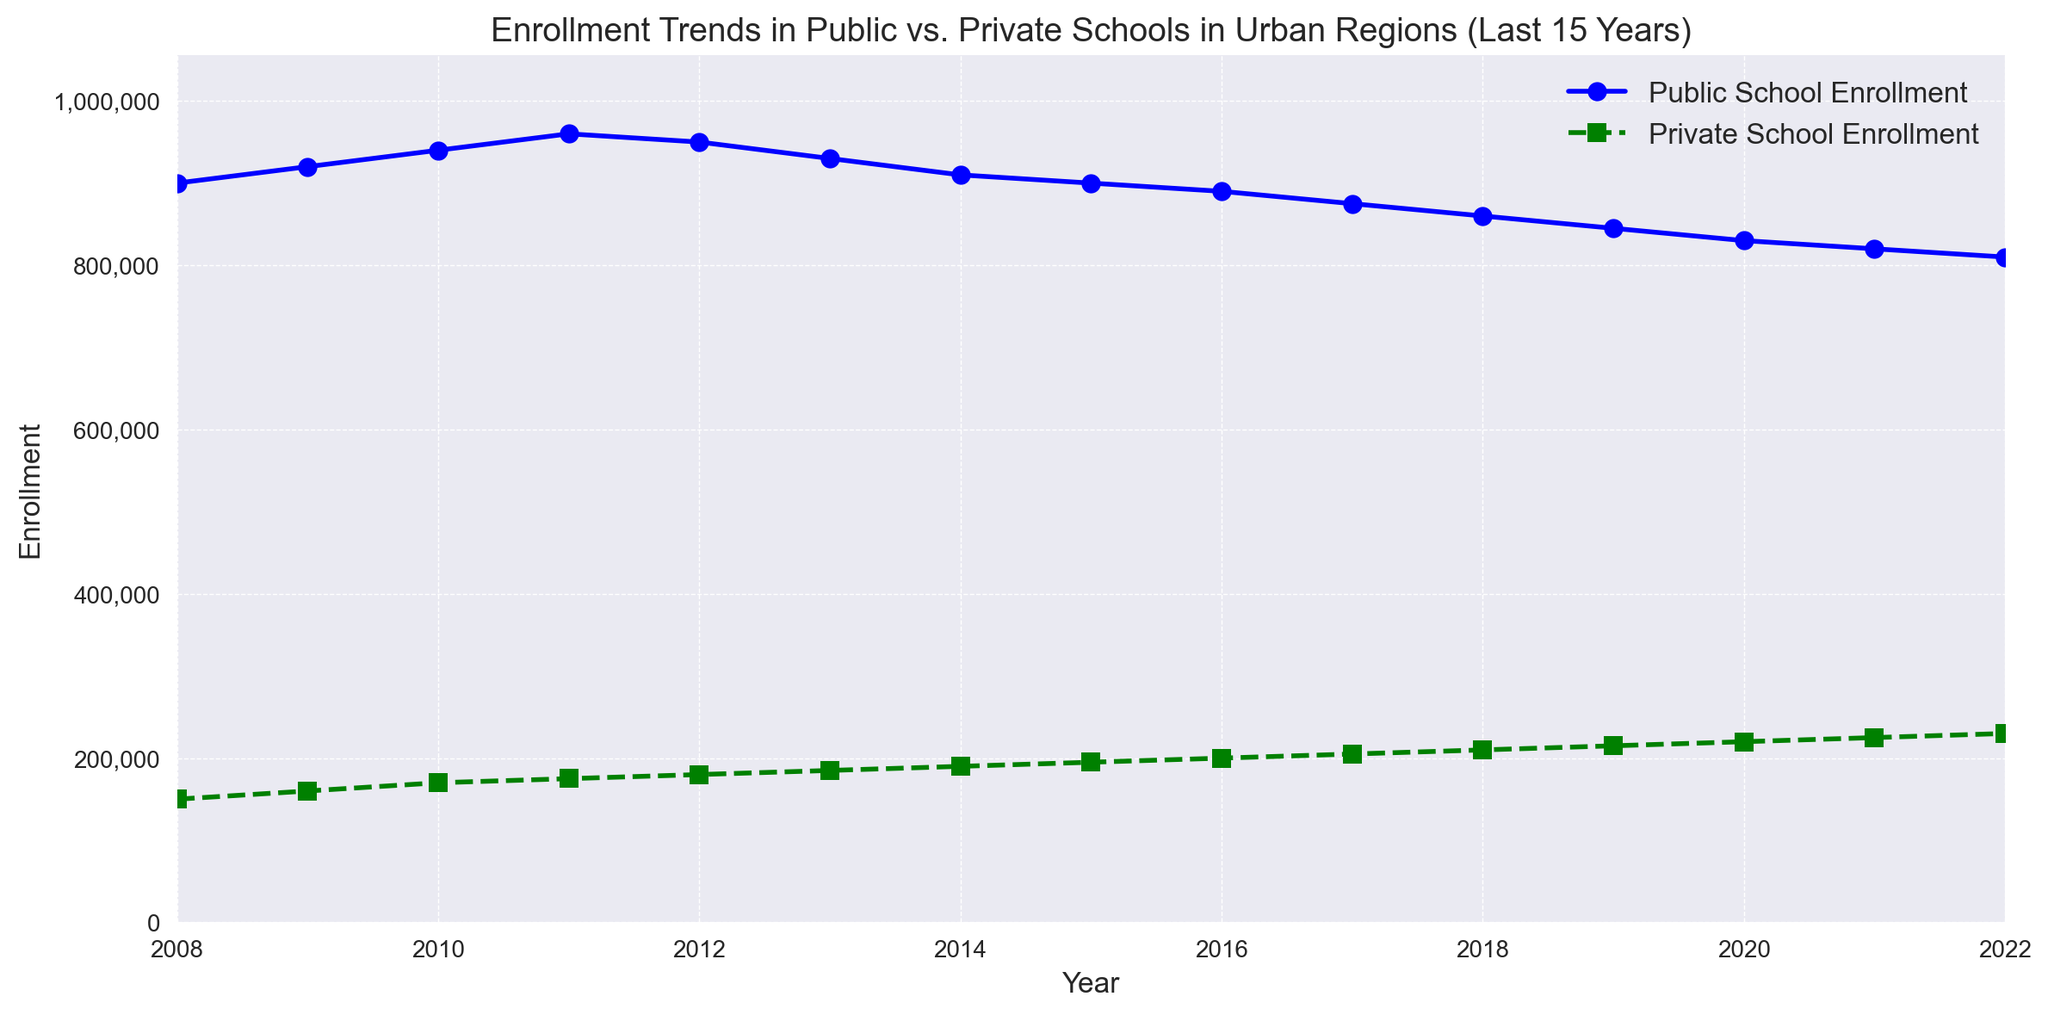What's the trend of Public School Enrollment over the last 15 years? By observing the blue line representing Public School Enrollment from 2008 to 2022, it generally shows a declining trend. Most years have a decrease in enrollment, except for a few initial years where there is a slight increase before it starts declining after 2011.
Answer: Declining In which years did Public School Enrollment reach its peak and trough? The peak of Public School Enrollment is observed in 2011 with 960,000 enrollments, and the trough is in 2022 with 810,000 enrollments, as seen on the blue line at those specific points on the graph.
Answer: Peak: 2011, Trough: 2022 How does the trend in Private School Enrollment compare to Public School Enrollment over time? By comparing the green dashed line (Private School Enrollment) and the blue continuous line (Public School Enrollment), Private School Enrollment shows a steady increase from 150,000 in 2008 to 230,000 in 2022, whereas Public School Enrollment shows a decline after a brief increase until 2011.
Answer: Private: Increasing, Public: Declining What is the average enrollment in private schools over the last 15 years? To determine the average, sum the Private School Enrollment values and divide by the number of years (15). Sum: (150,000 + 160,000 + 170,000 + 175,000 + 180,000 + 185,000 + 190,000 + 195,000 + 200,000 + 205,000 + 210,000 + 215,000 + 220,000 + 225,000 + 230,000) = 2,810,000. Average = 2,810,000 / 15.
Answer: 187,333 During which period did Public School Enrollment decline the most significantly? The most significant decline for Public School Enrollment is observed between 2011 and 2012, where the enrollment dropped from 960,000 to 950,000, and from 2013 to 2014, where enrollment dropped from 930,000 to 910,000. Observing these sequences, the drop is more rapid than other years.
Answer: 2011-2012 Calculate the absolute difference in enrollments between public and private schools in 2018. In 2018, Public School Enrollment is 860,000 and Private School Enrollment is 210,000. The absolute difference is calculated as 860,000 - 210,000.
Answer: 650,000 By how much has Private School Enrollment increased from 2008 to 2022? Private School Enrollment in 2008 was 150,000 and in 2022 it was 230,000. The increase is calculated as 230,000 - 150,000.
Answer: 80,000 What is the ratio of Private to Public School Enrollment in 2022? In 2022, Private School Enrollment is 230,000 and Public School Enrollment is 810,000. The ratio is obtained by dividing 230,000 by 810,000.
Answer: 0.284 Which year had the smallest gap between Public and Private School Enrollments? Comparing the differences in enrollments between public and private schools each year, the smallest gap is observed in 2022: Public (810,000) - Private (230,000) = 580,000, compared to larger differences in prior years.
Answer: 2022 When did the Private School Enrollment cross the 200,000 mark? By observing the green line, Private School Enrollment first crosses the 200,000 mark in the year 2016, where enrollment was 200,000.
Answer: 2016 